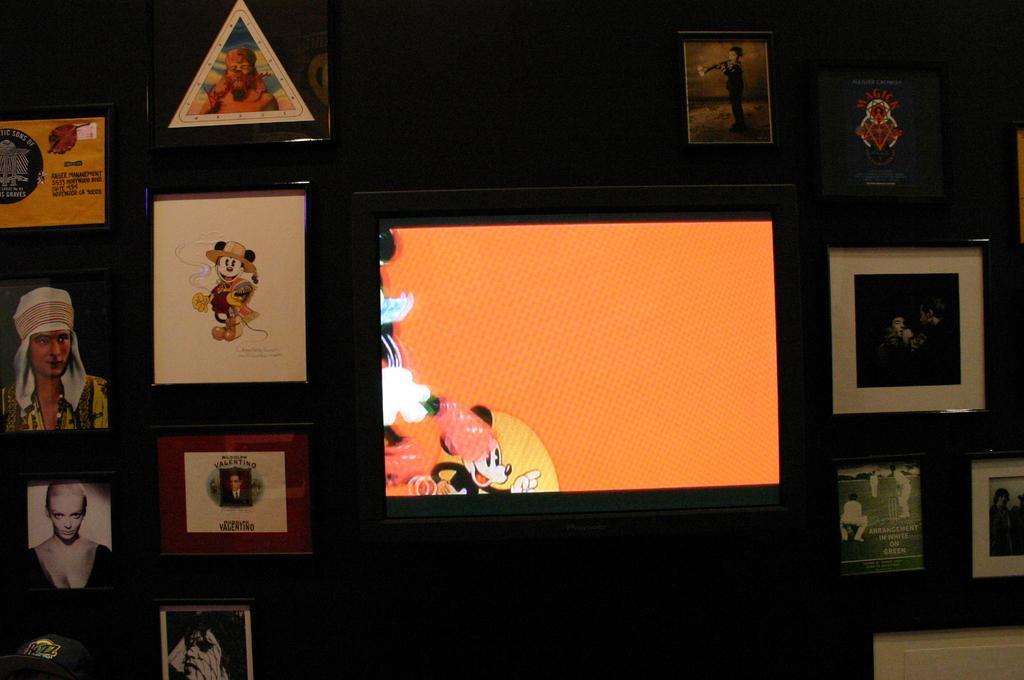In one or two sentences, can you explain what this image depicts? In the given picture, I can see a black color wall and few images which is sticked to the wall towards right i can see a picture of cricketers in image and also i can see a television next i can see a Mickey mouse. 